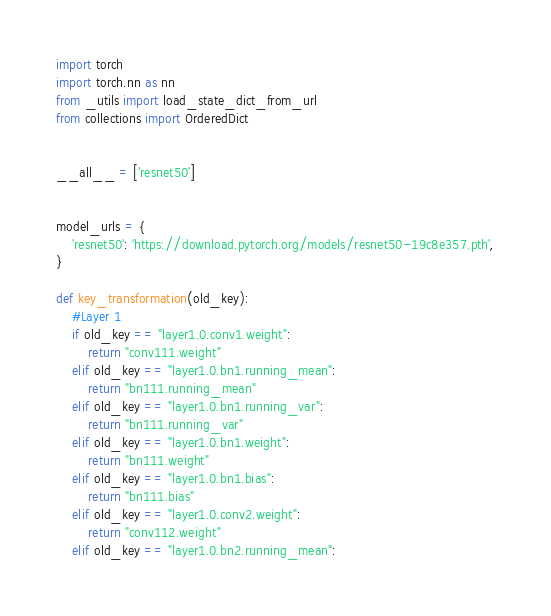<code> <loc_0><loc_0><loc_500><loc_500><_Python_>import torch
import torch.nn as nn
from _utils import load_state_dict_from_url
from collections import OrderedDict


__all__ = ['resnet50']


model_urls = {
    'resnet50': 'https://download.pytorch.org/models/resnet50-19c8e357.pth',
}
    
def key_transformation(old_key):
    #Layer 1
    if old_key == "layer1.0.conv1.weight":
        return "conv111.weight"
    elif old_key == "layer1.0.bn1.running_mean":
        return "bn111.running_mean"
    elif old_key == "layer1.0.bn1.running_var":
        return "bn111.running_var"
    elif old_key == "layer1.0.bn1.weight":
        return "bn111.weight"
    elif old_key == "layer1.0.bn1.bias":
        return "bn111.bias"
    elif old_key == "layer1.0.conv2.weight":
        return "conv112.weight"
    elif old_key == "layer1.0.bn2.running_mean":</code> 